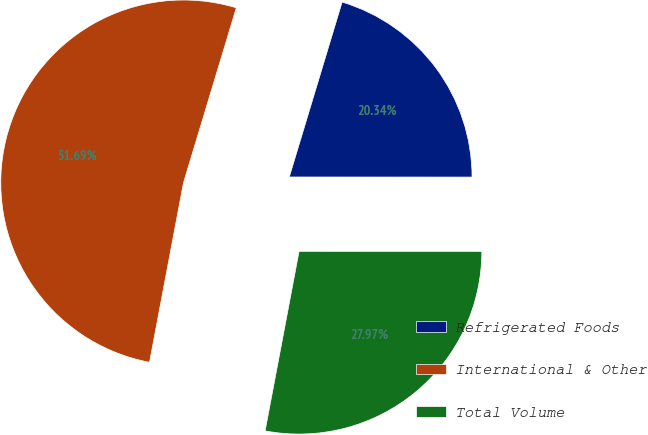Convert chart. <chart><loc_0><loc_0><loc_500><loc_500><pie_chart><fcel>Refrigerated Foods<fcel>International & Other<fcel>Total Volume<nl><fcel>20.34%<fcel>51.69%<fcel>27.97%<nl></chart> 